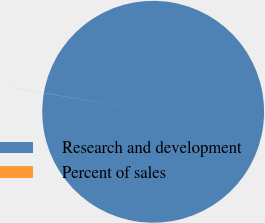Convert chart. <chart><loc_0><loc_0><loc_500><loc_500><pie_chart><fcel>Research and development<fcel>Percent of sales<nl><fcel>99.98%<fcel>0.02%<nl></chart> 